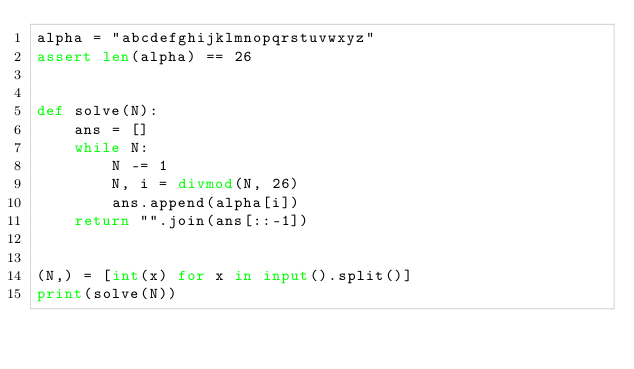Convert code to text. <code><loc_0><loc_0><loc_500><loc_500><_Python_>alpha = "abcdefghijklmnopqrstuvwxyz"
assert len(alpha) == 26


def solve(N):
    ans = []
    while N:
        N -= 1
        N, i = divmod(N, 26)
        ans.append(alpha[i])
    return "".join(ans[::-1])


(N,) = [int(x) for x in input().split()]
print(solve(N))

</code> 